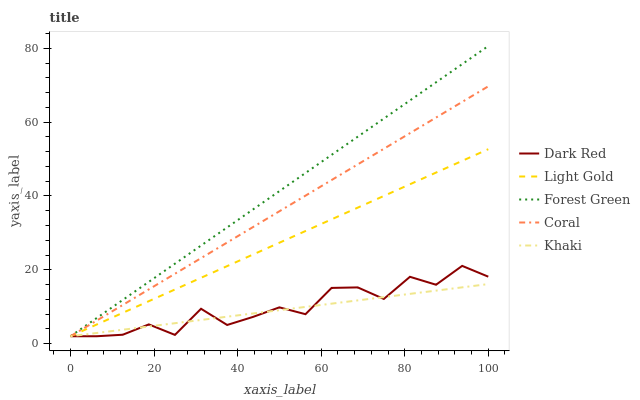Does Khaki have the minimum area under the curve?
Answer yes or no. Yes. Does Forest Green have the maximum area under the curve?
Answer yes or no. Yes. Does Forest Green have the minimum area under the curve?
Answer yes or no. No. Does Khaki have the maximum area under the curve?
Answer yes or no. No. Is Khaki the smoothest?
Answer yes or no. Yes. Is Dark Red the roughest?
Answer yes or no. Yes. Is Forest Green the smoothest?
Answer yes or no. No. Is Forest Green the roughest?
Answer yes or no. No. Does Dark Red have the lowest value?
Answer yes or no. Yes. Does Forest Green have the highest value?
Answer yes or no. Yes. Does Khaki have the highest value?
Answer yes or no. No. Does Light Gold intersect Khaki?
Answer yes or no. Yes. Is Light Gold less than Khaki?
Answer yes or no. No. Is Light Gold greater than Khaki?
Answer yes or no. No. 